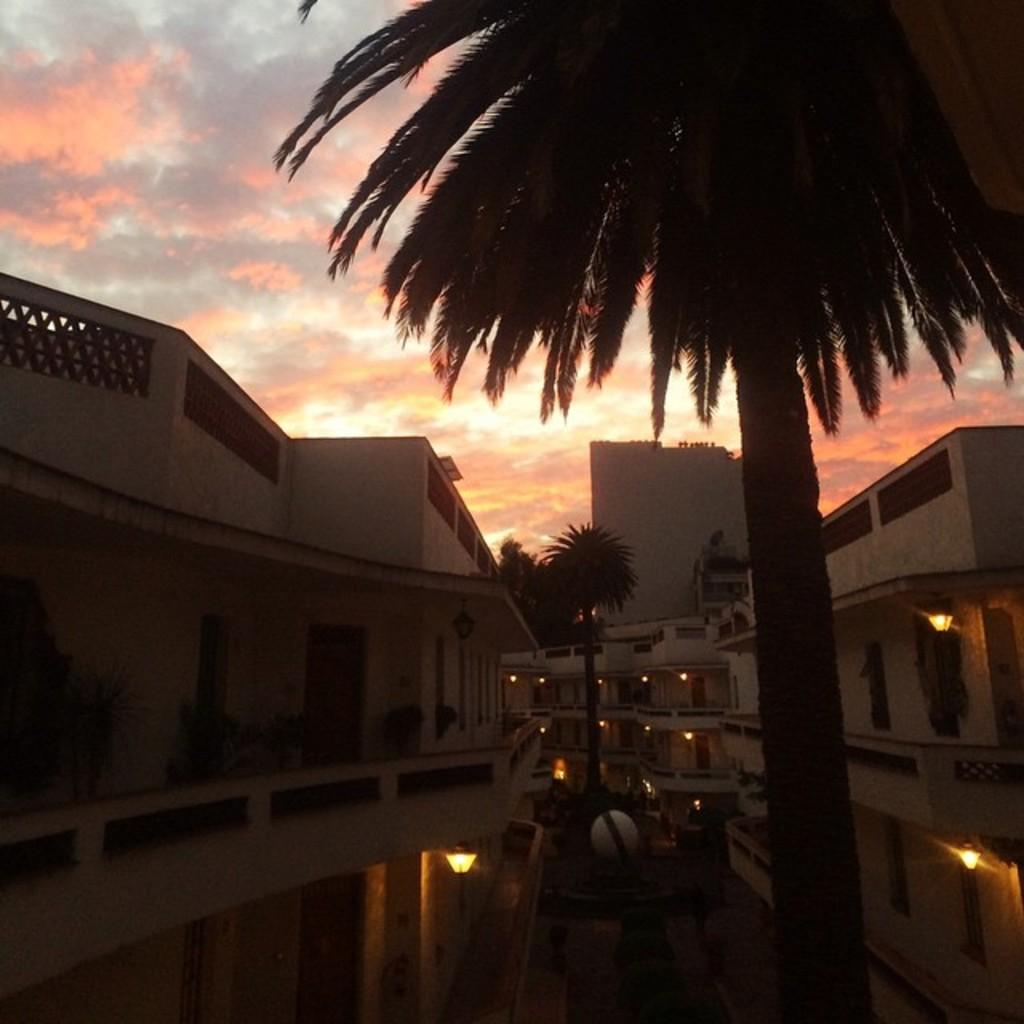What is located in the middle of the image? There are trees in the middle of the image. What can be seen in the background of the image? There are buildings in the background of the image. What is visible at the top of the image? The sky is visible at the top of the image. Can you see any veins in the image? There are no veins present in the image; it features trees, buildings, and the sky. Is there a boat visible in the image? There is no boat present in the image. 